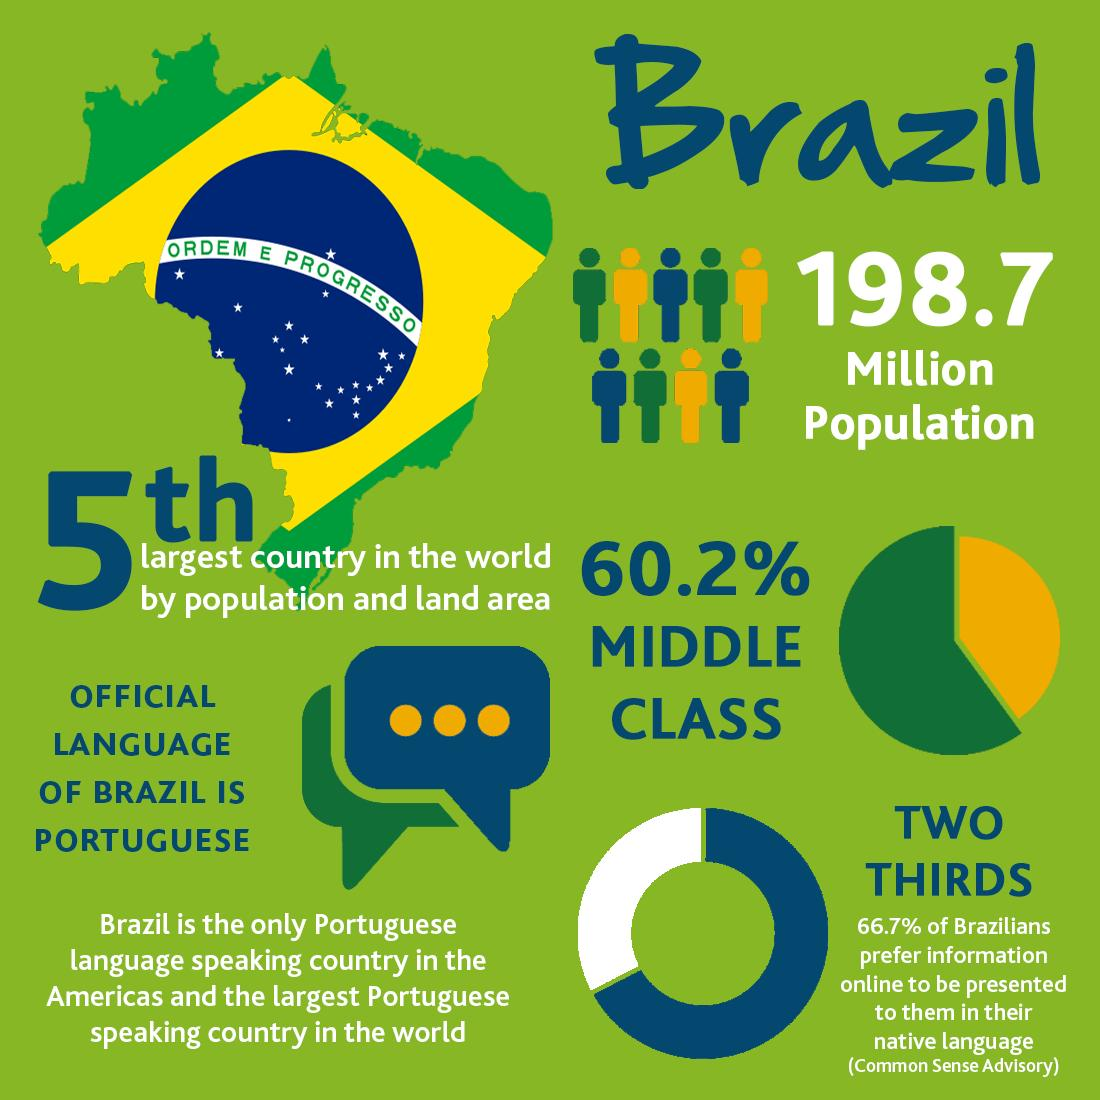Point out several critical features in this image. According to data, approximately 39.8% of the population of Brazil does not belong to the middle class. 